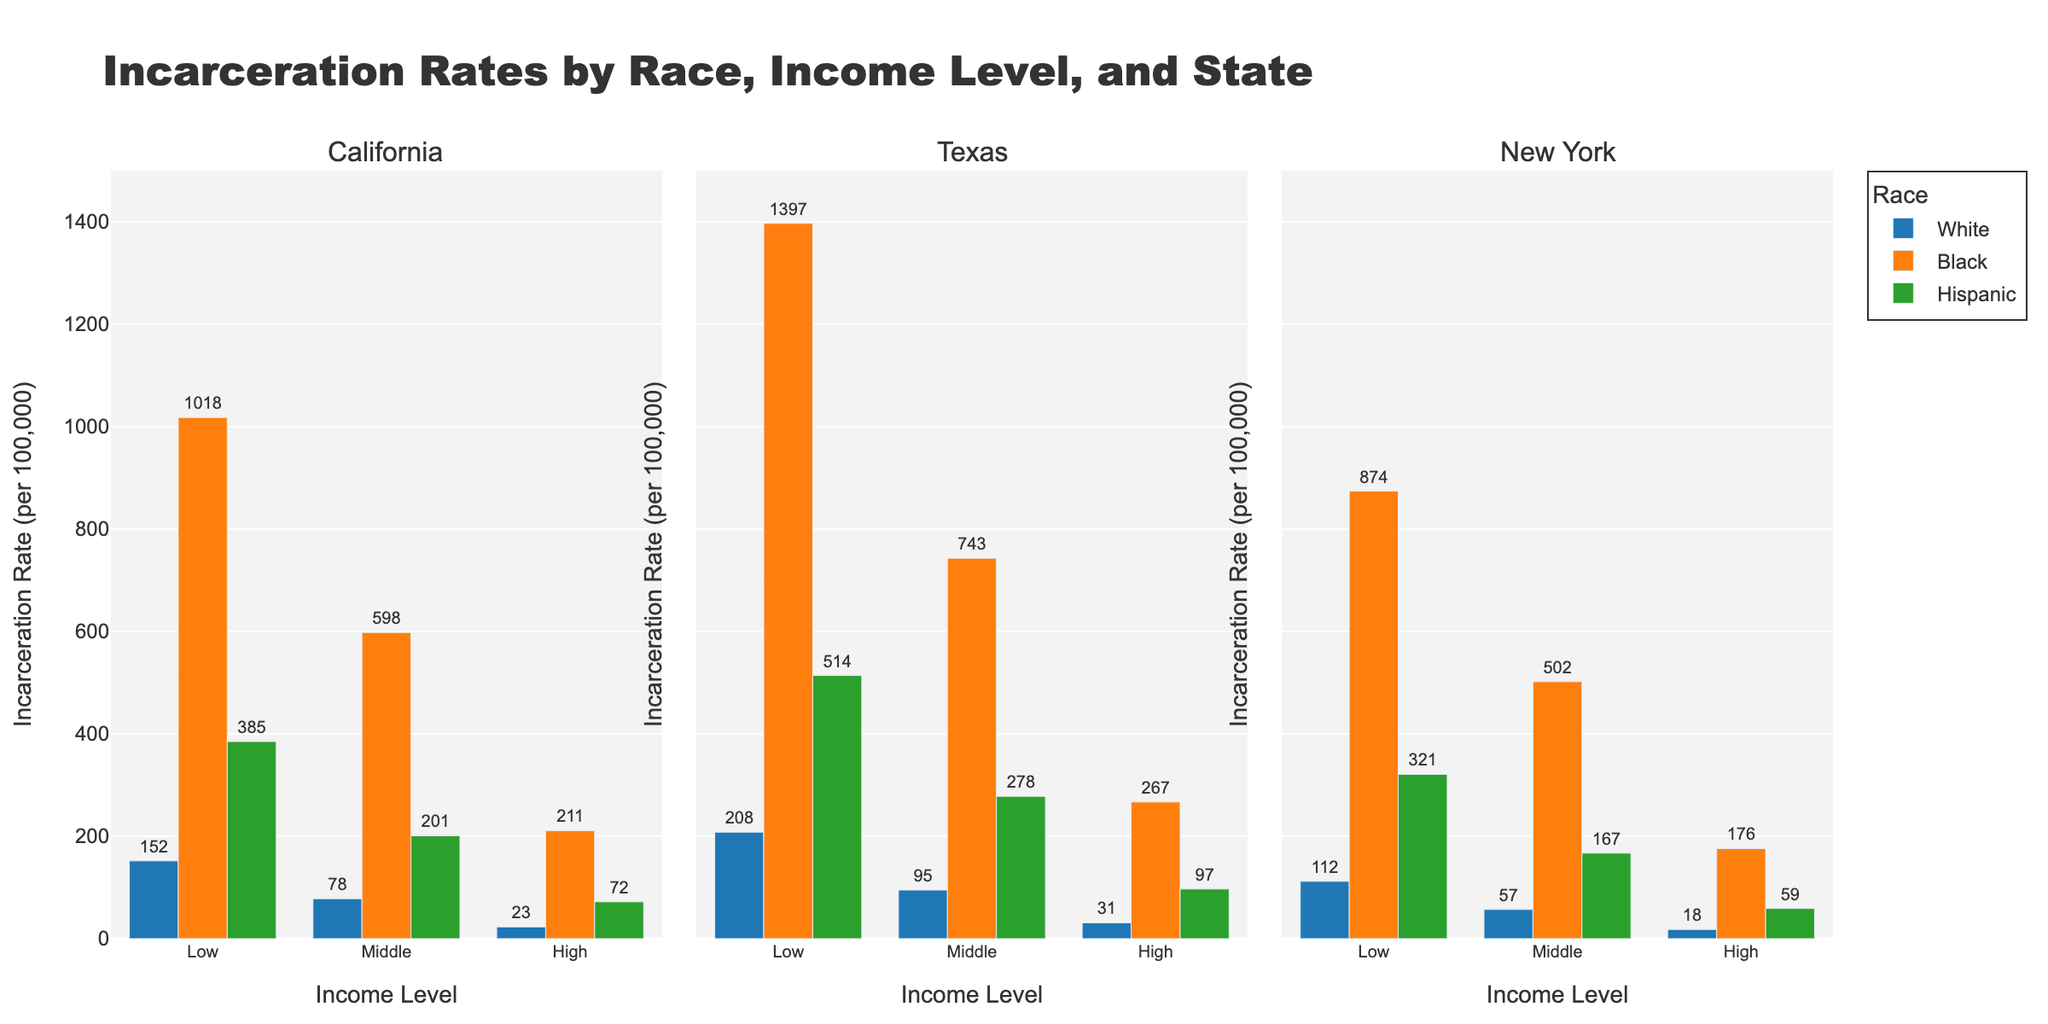Which renewable energy source had the highest production in 2013? Look at the first row of each subplot. Compare the values for Solar, Wind, Hydropower, Bioenergy, and Geothermal in 2013. Hydropower has the highest value of 3789 TWh.
Answer: Hydropower What was the trend in solar energy production over the past decade? Check the Solar subplot from 2013 to 2022. The production increased consistently from 139 TWh in 2013 to 1289 TWh in 2022.
Answer: Increasing Compare the growth in production between Wind and Solar energy from 2013 to 2022. Which grew more? Calculate the difference in production for both sources between 2022 and 2013. For Solar: 1289 - 139 = 1150 TWh. For Wind: 2110 - 641 = 1469 TWh. Wind energy grew more.
Answer: Wind What is the average production of Bioenergy from 2013 to 2022? Sum the Bioenergy values over the years and divide by the number of years. (428 + 456 + 474 + 503 + 532 + 556 + 583 + 608 + 632 + 657) / 10 = 5429 / 10 = 542.9 TWh.
Answer: 542.9 TWh How did Hydropower production change from 2013 to 2022? Check the Hydropower subplot for values in 2013 and 2022. In 2013, it was 3789 TWh, and in 2022, it was 4358 TWh. The increase is 4358 - 3789 = 569 TWh.
Answer: Increased by 569 TWh Which year showed the highest production of Geothermal energy and how much was it? Look at the Geothermal subplot. The year 2022 had the highest production at 103 TWh.
Answer: 2022, 103 TWh Among the five energy sources, which had the least variance in production over the decade? Visually inspect the subplots for the range of production values. Geothermal seems to have the smallest range. The variance is lowest because its production values are within a small interval from 76 to 103 TWh.
Answer: Geothermal What is the total renewable energy production for all sources combined in 2020? Add the production values of all sources for 2020. Solar: 821, Wind: 1592, Hydropower: 4297, Bioenergy: 608, Geothermal: 97. Total = 821 + 1592 + 4297 + 608 + 97 = 7415 TWh.
Answer: 7415 TWh Between Solar and Bioenergy, which had a more consistent year-over-year growth pattern? Compare the year-over-year changes in the subplots. Solar shows a more consistent upward trend each year, whereas Bioenergy has smaller and less consistent increments.
Answer: Solar What is the difference in Wind energy production between 2015 and 2022? Look at the Wind subplot for values in 2015 and 2022. The values are 831 TWh in 2015 and 2110 TWh in 2022. The difference is 2110 - 831 = 1279 TWh.
Answer: 1279 TWh 